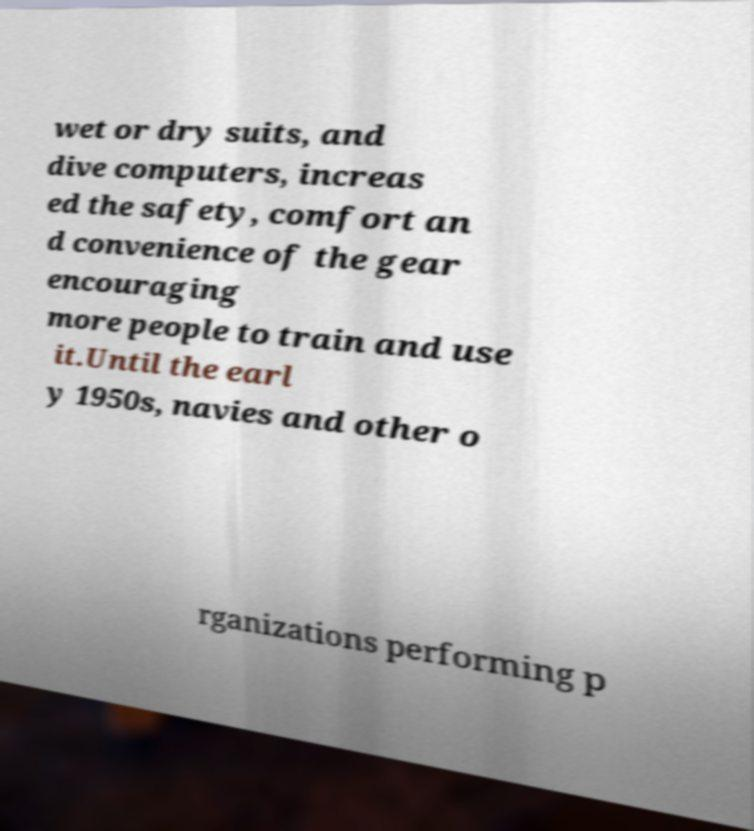Please read and relay the text visible in this image. What does it say? wet or dry suits, and dive computers, increas ed the safety, comfort an d convenience of the gear encouraging more people to train and use it.Until the earl y 1950s, navies and other o rganizations performing p 